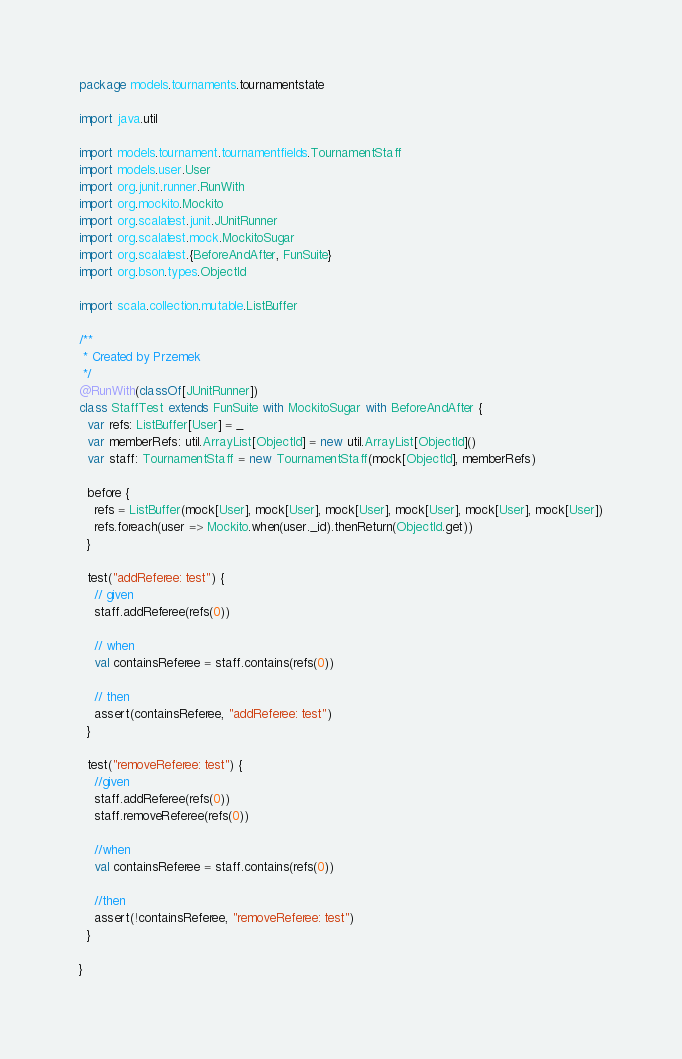<code> <loc_0><loc_0><loc_500><loc_500><_Scala_>package models.tournaments.tournamentstate

import java.util

import models.tournament.tournamentfields.TournamentStaff
import models.user.User
import org.junit.runner.RunWith
import org.mockito.Mockito
import org.scalatest.junit.JUnitRunner
import org.scalatest.mock.MockitoSugar
import org.scalatest.{BeforeAndAfter, FunSuite}
import org.bson.types.ObjectId

import scala.collection.mutable.ListBuffer

/**
 * Created by Przemek
 */
@RunWith(classOf[JUnitRunner])
class StaffTest extends FunSuite with MockitoSugar with BeforeAndAfter {
  var refs: ListBuffer[User] = _
  var memberRefs: util.ArrayList[ObjectId] = new util.ArrayList[ObjectId]()
  var staff: TournamentStaff = new TournamentStaff(mock[ObjectId], memberRefs)

  before {
    refs = ListBuffer(mock[User], mock[User], mock[User], mock[User], mock[User], mock[User])
    refs.foreach(user => Mockito.when(user._id).thenReturn(ObjectId.get))
  }

  test("addReferee: test") {
    // given
    staff.addReferee(refs(0))

    // when
    val containsReferee = staff.contains(refs(0))

    // then
    assert(containsReferee, "addReferee: test")
  }

  test("removeReferee: test") {
    //given
    staff.addReferee(refs(0))
    staff.removeReferee(refs(0))

    //when
    val containsReferee = staff.contains(refs(0))

    //then
    assert(!containsReferee, "removeReferee: test")
  }

}
</code> 